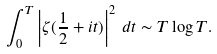<formula> <loc_0><loc_0><loc_500><loc_500>\int _ { 0 } ^ { T } \left | \zeta ( \frac { 1 } { 2 } + i t ) \right | ^ { 2 } \, d t \sim T \log T .</formula> 